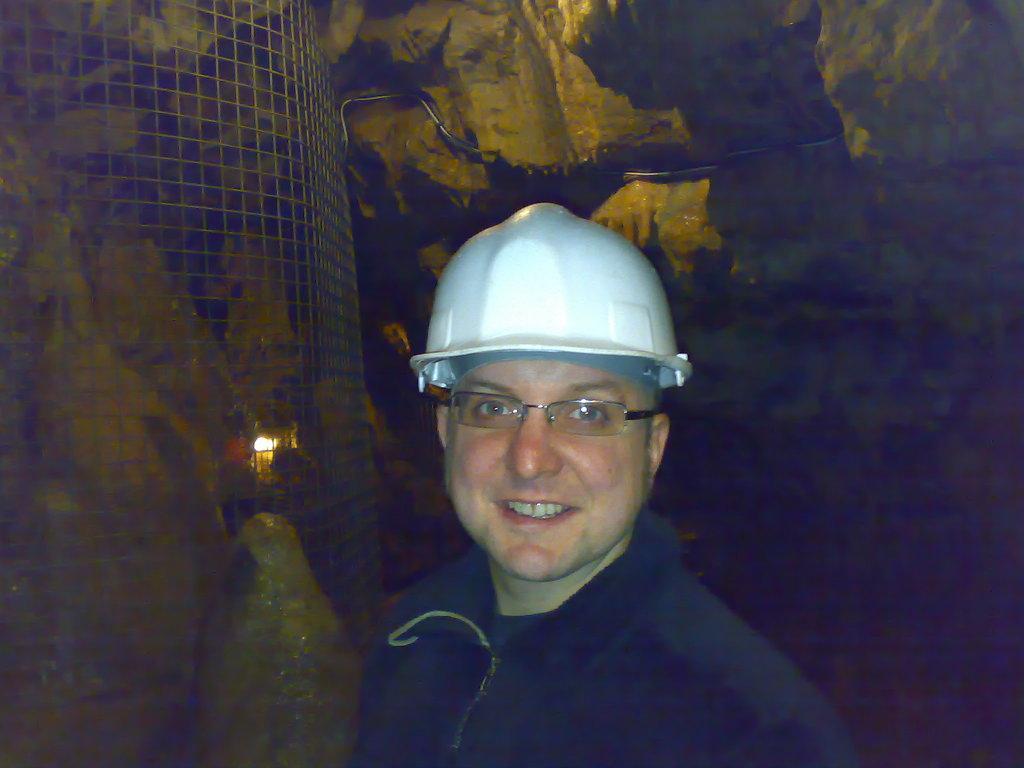Can you describe this image briefly? In the picture we can see a man wearing a white helmet and beside him we can see the fencing and behind him we can see the dark. 